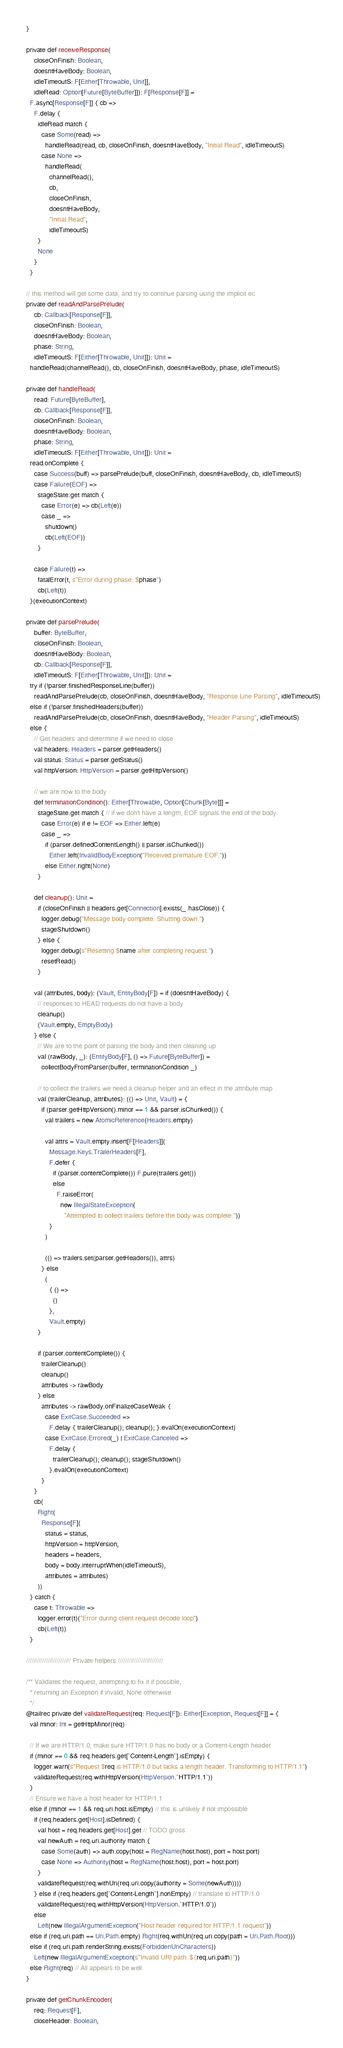Convert code to text. <code><loc_0><loc_0><loc_500><loc_500><_Scala_>  }

  private def receiveResponse(
      closeOnFinish: Boolean,
      doesntHaveBody: Boolean,
      idleTimeoutS: F[Either[Throwable, Unit]],
      idleRead: Option[Future[ByteBuffer]]): F[Response[F]] =
    F.async[Response[F]] { cb =>
      F.delay {
        idleRead match {
          case Some(read) =>
            handleRead(read, cb, closeOnFinish, doesntHaveBody, "Initial Read", idleTimeoutS)
          case None =>
            handleRead(
              channelRead(),
              cb,
              closeOnFinish,
              doesntHaveBody,
              "Initial Read",
              idleTimeoutS)
        }
        None
      }
    }

  // this method will get some data, and try to continue parsing using the implicit ec
  private def readAndParsePrelude(
      cb: Callback[Response[F]],
      closeOnFinish: Boolean,
      doesntHaveBody: Boolean,
      phase: String,
      idleTimeoutS: F[Either[Throwable, Unit]]): Unit =
    handleRead(channelRead(), cb, closeOnFinish, doesntHaveBody, phase, idleTimeoutS)

  private def handleRead(
      read: Future[ByteBuffer],
      cb: Callback[Response[F]],
      closeOnFinish: Boolean,
      doesntHaveBody: Boolean,
      phase: String,
      idleTimeoutS: F[Either[Throwable, Unit]]): Unit =
    read.onComplete {
      case Success(buff) => parsePrelude(buff, closeOnFinish, doesntHaveBody, cb, idleTimeoutS)
      case Failure(EOF) =>
        stageState.get match {
          case Error(e) => cb(Left(e))
          case _ =>
            shutdown()
            cb(Left(EOF))
        }

      case Failure(t) =>
        fatalError(t, s"Error during phase: $phase")
        cb(Left(t))
    }(executionContext)

  private def parsePrelude(
      buffer: ByteBuffer,
      closeOnFinish: Boolean,
      doesntHaveBody: Boolean,
      cb: Callback[Response[F]],
      idleTimeoutS: F[Either[Throwable, Unit]]): Unit =
    try if (!parser.finishedResponseLine(buffer))
      readAndParsePrelude(cb, closeOnFinish, doesntHaveBody, "Response Line Parsing", idleTimeoutS)
    else if (!parser.finishedHeaders(buffer))
      readAndParsePrelude(cb, closeOnFinish, doesntHaveBody, "Header Parsing", idleTimeoutS)
    else {
      // Get headers and determine if we need to close
      val headers: Headers = parser.getHeaders()
      val status: Status = parser.getStatus()
      val httpVersion: HttpVersion = parser.getHttpVersion()

      // we are now to the body
      def terminationCondition(): Either[Throwable, Option[Chunk[Byte]]] =
        stageState.get match { // if we don't have a length, EOF signals the end of the body.
          case Error(e) if e != EOF => Either.left(e)
          case _ =>
            if (parser.definedContentLength() || parser.isChunked())
              Either.left(InvalidBodyException("Received premature EOF."))
            else Either.right(None)
        }

      def cleanup(): Unit =
        if (closeOnFinish || headers.get[Connection].exists(_.hasClose)) {
          logger.debug("Message body complete. Shutting down.")
          stageShutdown()
        } else {
          logger.debug(s"Resetting $name after completing request.")
          resetRead()
        }

      val (attributes, body): (Vault, EntityBody[F]) = if (doesntHaveBody) {
        // responses to HEAD requests do not have a body
        cleanup()
        (Vault.empty, EmptyBody)
      } else {
        // We are to the point of parsing the body and then cleaning up
        val (rawBody, _): (EntityBody[F], () => Future[ByteBuffer]) =
          collectBodyFromParser(buffer, terminationCondition _)

        // to collect the trailers we need a cleanup helper and an effect in the attribute map
        val (trailerCleanup, attributes): (() => Unit, Vault) = {
          if (parser.getHttpVersion().minor == 1 && parser.isChunked()) {
            val trailers = new AtomicReference(Headers.empty)

            val attrs = Vault.empty.insert[F[Headers]](
              Message.Keys.TrailerHeaders[F],
              F.defer {
                if (parser.contentComplete()) F.pure(trailers.get())
                else
                  F.raiseError(
                    new IllegalStateException(
                      "Attempted to collect trailers before the body was complete."))
              }
            )

            (() => trailers.set(parser.getHeaders()), attrs)
          } else
            (
              { () =>
                ()
              },
              Vault.empty)
        }

        if (parser.contentComplete()) {
          trailerCleanup()
          cleanup()
          attributes -> rawBody
        } else
          attributes -> rawBody.onFinalizeCaseWeak {
            case ExitCase.Succeeded =>
              F.delay { trailerCleanup(); cleanup(); }.evalOn(executionContext)
            case ExitCase.Errored(_) | ExitCase.Canceled =>
              F.delay {
                trailerCleanup(); cleanup(); stageShutdown()
              }.evalOn(executionContext)
          }
      }
      cb(
        Right(
          Response[F](
            status = status,
            httpVersion = httpVersion,
            headers = headers,
            body = body.interruptWhen(idleTimeoutS),
            attributes = attributes)
        ))
    } catch {
      case t: Throwable =>
        logger.error(t)("Error during client request decode loop")
        cb(Left(t))
    }

  ///////////////////////// Private helpers /////////////////////////

  /** Validates the request, attempting to fix it if possible,
    * returning an Exception if invalid, None otherwise
    */
  @tailrec private def validateRequest(req: Request[F]): Either[Exception, Request[F]] = {
    val minor: Int = getHttpMinor(req)

    // If we are HTTP/1.0, make sure HTTP/1.0 has no body or a Content-Length header
    if (minor == 0 && req.headers.get[`Content-Length`].isEmpty) {
      logger.warn(s"Request $req is HTTP/1.0 but lacks a length header. Transforming to HTTP/1.1")
      validateRequest(req.withHttpVersion(HttpVersion.`HTTP/1.1`))
    }
    // Ensure we have a host header for HTTP/1.1
    else if (minor == 1 && req.uri.host.isEmpty) // this is unlikely if not impossible
      if (req.headers.get[Host].isDefined) {
        val host = req.headers.get[Host].get // TODO gross
        val newAuth = req.uri.authority match {
          case Some(auth) => auth.copy(host = RegName(host.host), port = host.port)
          case None => Authority(host = RegName(host.host), port = host.port)
        }
        validateRequest(req.withUri(req.uri.copy(authority = Some(newAuth))))
      } else if (req.headers.get[`Content-Length`].nonEmpty) // translate to HTTP/1.0
        validateRequest(req.withHttpVersion(HttpVersion.`HTTP/1.0`))
      else
        Left(new IllegalArgumentException("Host header required for HTTP/1.1 request"))
    else if (req.uri.path == Uri.Path.empty) Right(req.withUri(req.uri.copy(path = Uri.Path.Root)))
    else if (req.uri.path.renderString.exists(ForbiddenUriCharacters))
      Left(new IllegalArgumentException(s"Invalid URI path: ${req.uri.path}"))
    else Right(req) // All appears to be well
  }

  private def getChunkEncoder(
      req: Request[F],
      closeHeader: Boolean,</code> 